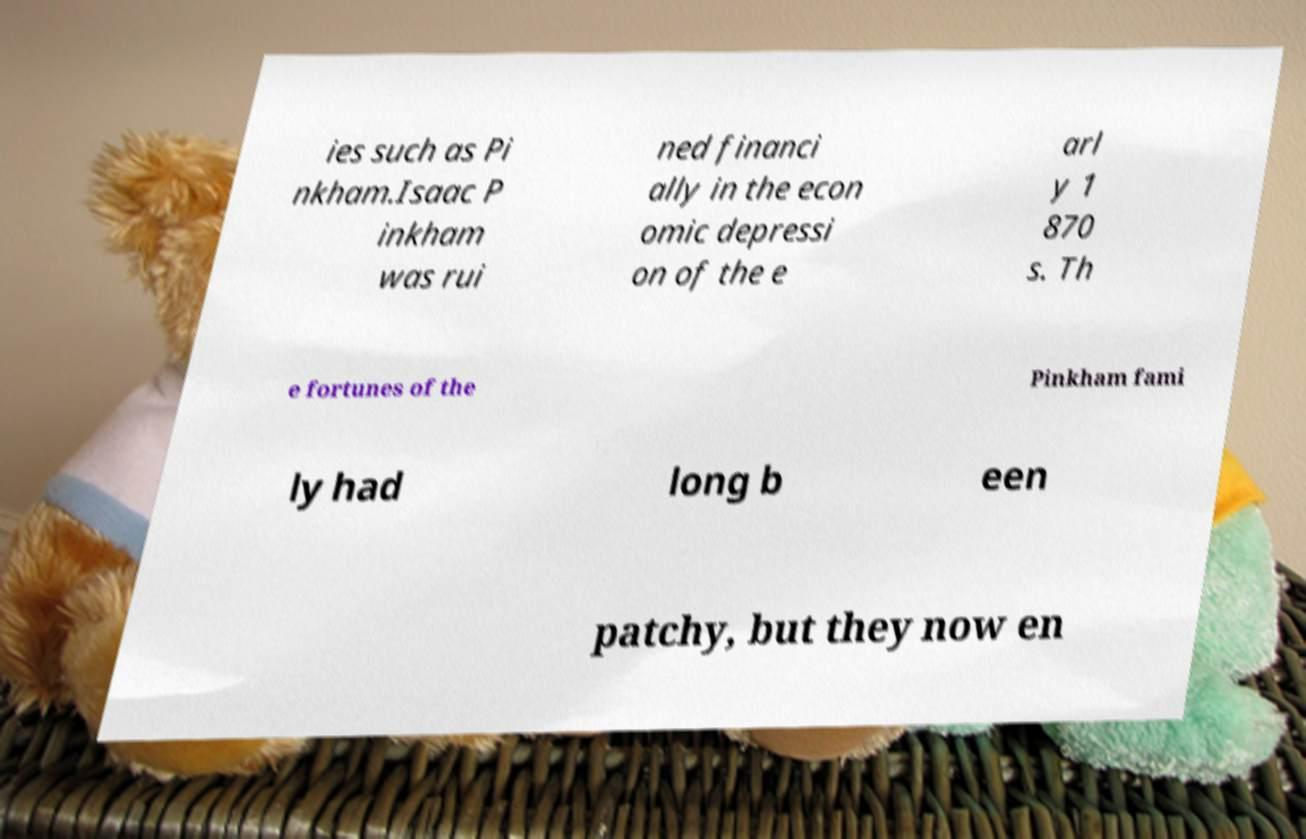For documentation purposes, I need the text within this image transcribed. Could you provide that? ies such as Pi nkham.Isaac P inkham was rui ned financi ally in the econ omic depressi on of the e arl y 1 870 s. Th e fortunes of the Pinkham fami ly had long b een patchy, but they now en 